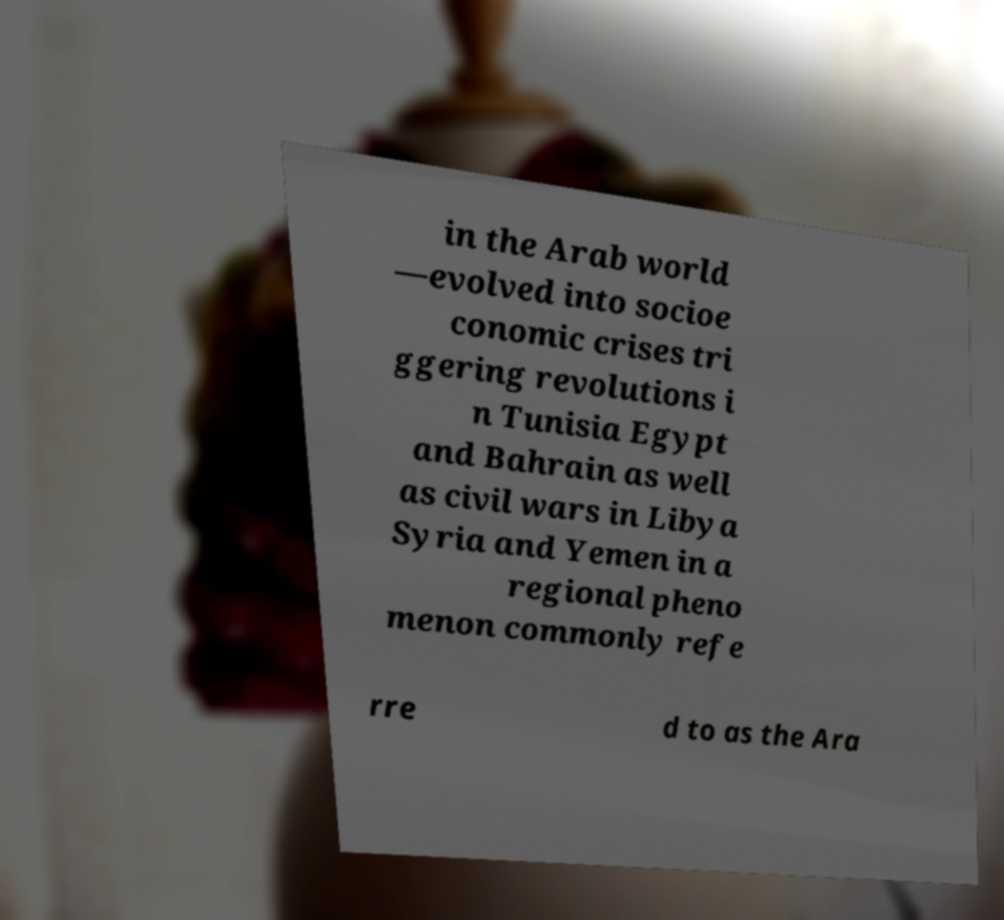Can you read and provide the text displayed in the image?This photo seems to have some interesting text. Can you extract and type it out for me? in the Arab world —evolved into socioe conomic crises tri ggering revolutions i n Tunisia Egypt and Bahrain as well as civil wars in Libya Syria and Yemen in a regional pheno menon commonly refe rre d to as the Ara 